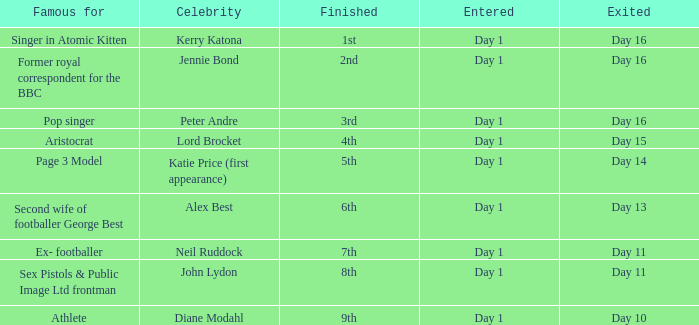Name who was famous for finished in 9th Athlete. 